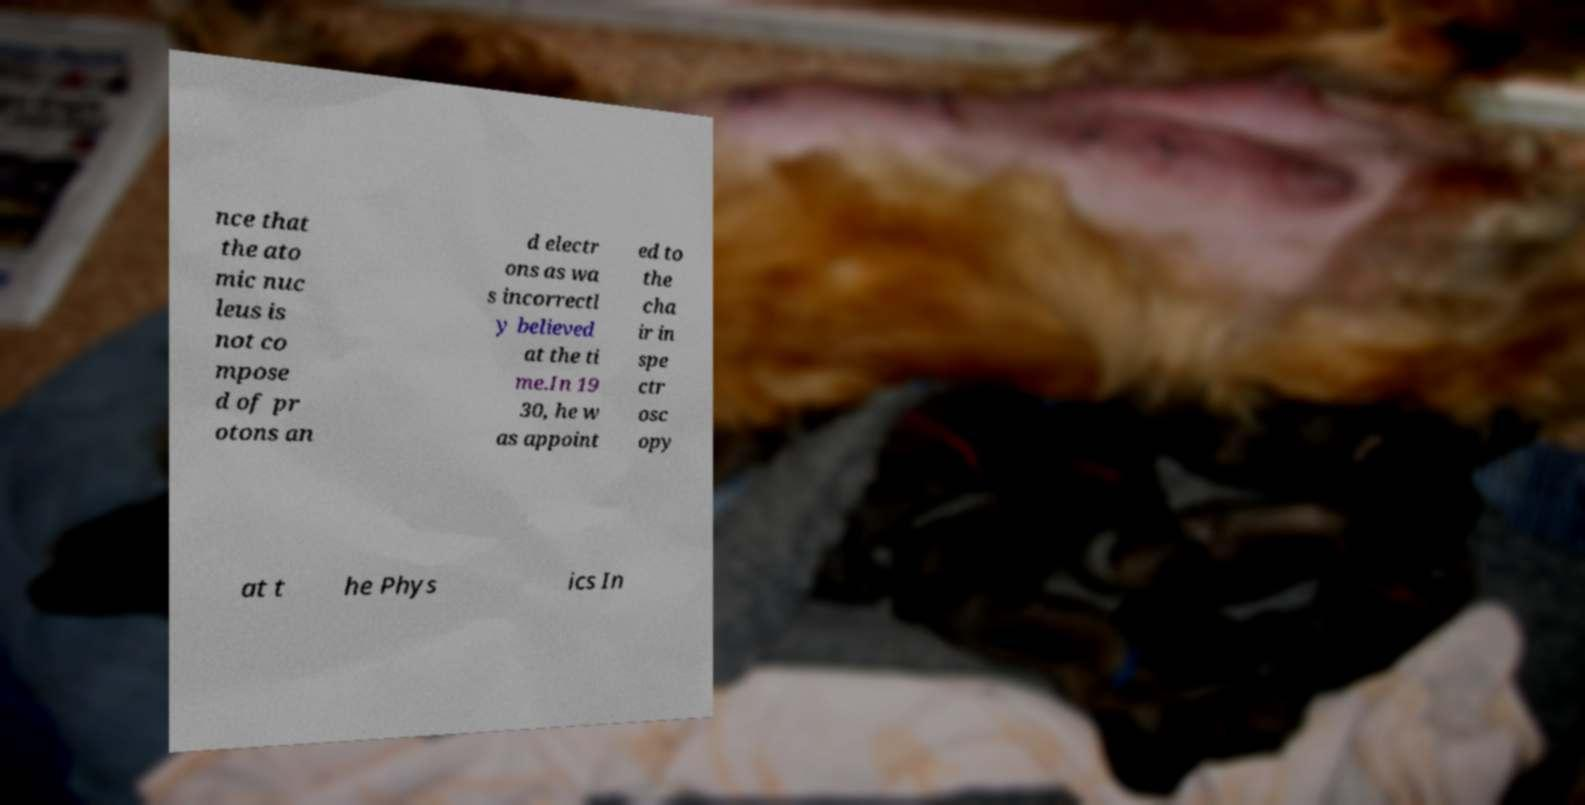Can you read and provide the text displayed in the image?This photo seems to have some interesting text. Can you extract and type it out for me? nce that the ato mic nuc leus is not co mpose d of pr otons an d electr ons as wa s incorrectl y believed at the ti me.In 19 30, he w as appoint ed to the cha ir in spe ctr osc opy at t he Phys ics In 